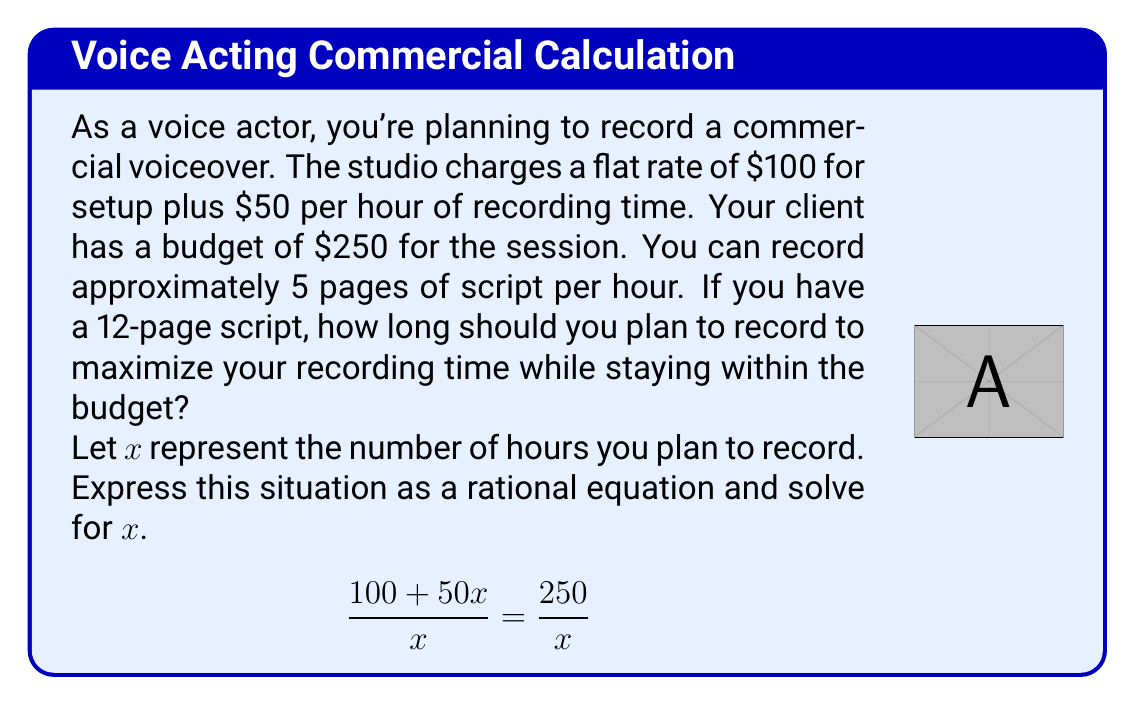What is the answer to this math problem? Let's solve this step-by-step:

1) First, we set up the rational equation:
   $$\frac{100 + 50x}{x} = \frac{250}{x}$$

2) Multiply both sides by $x$ to clear the denominators:
   $$(100 + 50x) = 250$$

3) Subtract 100 from both sides:
   $$50x = 150$$

4) Divide both sides by 50:
   $$x = 3$$

5) Check if this solution satisfies the original equation:
   $$\frac{100 + 50(3)}{3} = \frac{250}{3}$$
   $$\frac{250}{3} = \frac{250}{3}$$ (True)

6) Interpret the result:
   You should plan to record for 3 hours to maximize your recording time while staying within the budget.

7) Verify if this is sufficient for the 12-page script:
   At 5 pages per hour, you can record 15 pages in 3 hours, which is more than enough for your 12-page script.
Answer: 3 hours 